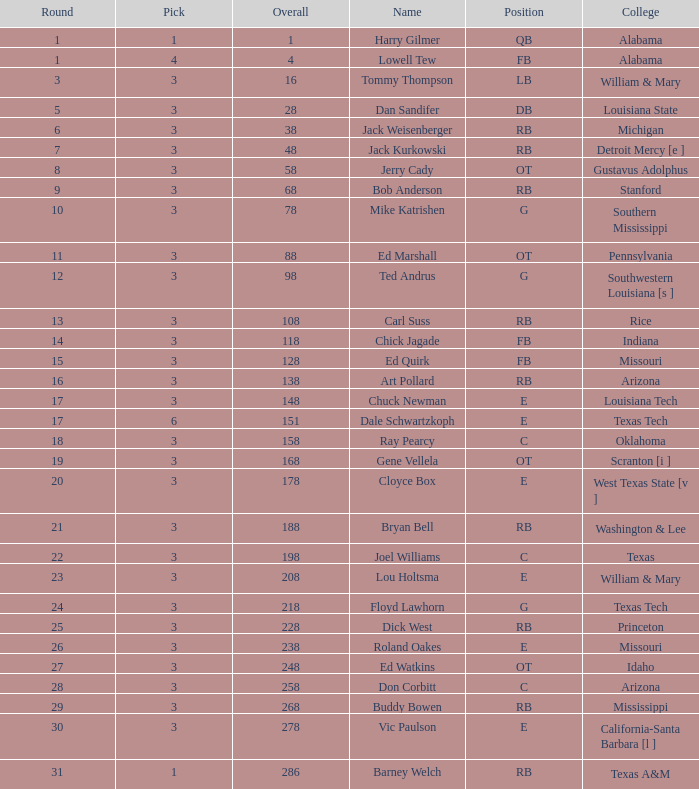Which selection has a round less than 8, an overall less than 16, and a name of harry gilmer? 1.0. 